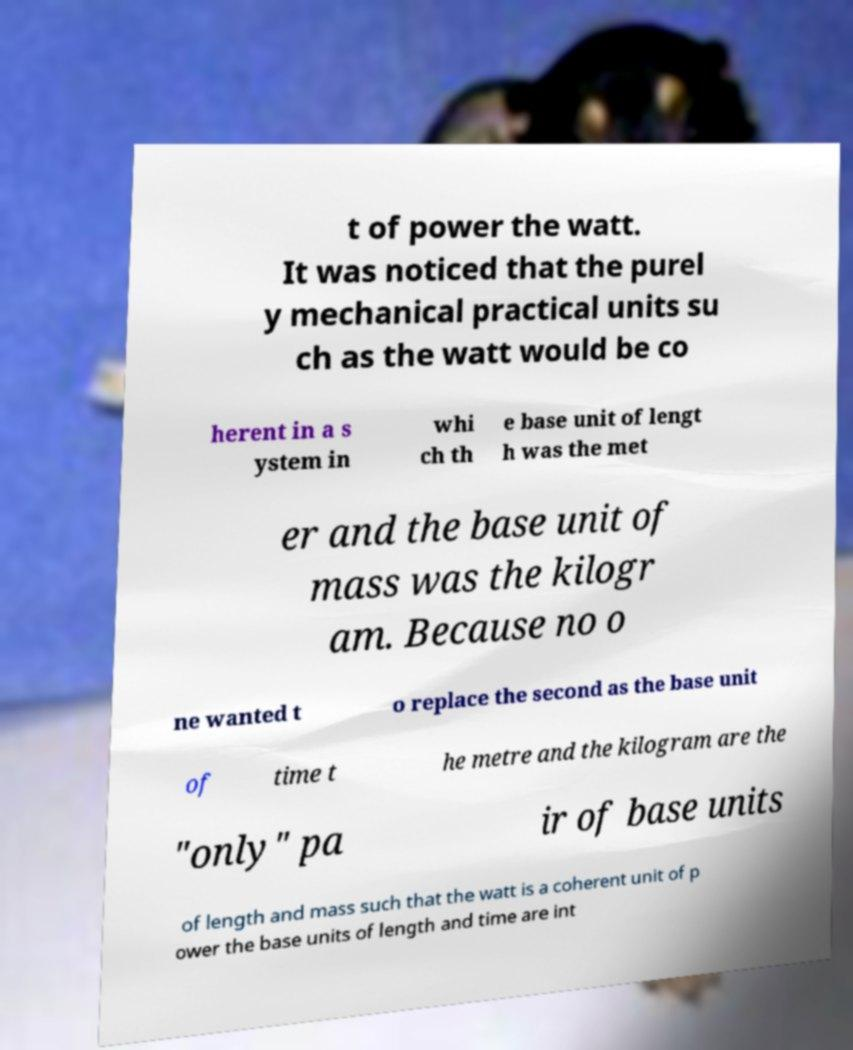For documentation purposes, I need the text within this image transcribed. Could you provide that? t of power the watt. It was noticed that the purel y mechanical practical units su ch as the watt would be co herent in a s ystem in whi ch th e base unit of lengt h was the met er and the base unit of mass was the kilogr am. Because no o ne wanted t o replace the second as the base unit of time t he metre and the kilogram are the "only" pa ir of base units of length and mass such that the watt is a coherent unit of p ower the base units of length and time are int 